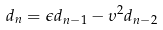<formula> <loc_0><loc_0><loc_500><loc_500>d _ { n } = \epsilon d _ { n - 1 } - \upsilon ^ { 2 } d _ { n - 2 }</formula> 